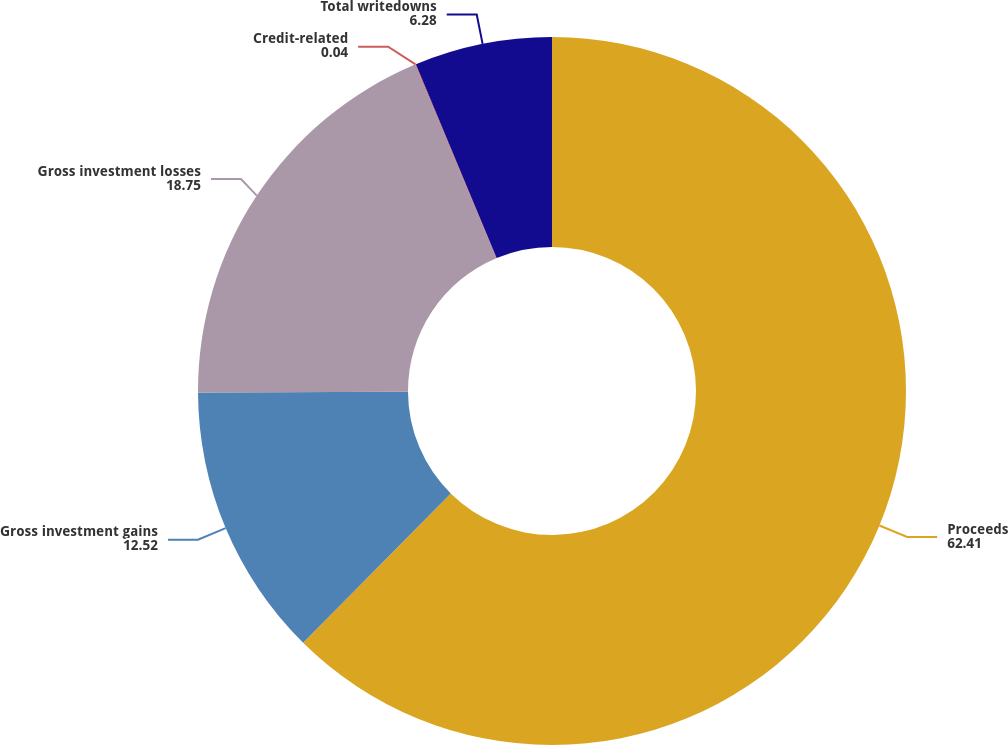Convert chart. <chart><loc_0><loc_0><loc_500><loc_500><pie_chart><fcel>Proceeds<fcel>Gross investment gains<fcel>Gross investment losses<fcel>Credit-related<fcel>Total writedowns<nl><fcel>62.41%<fcel>12.52%<fcel>18.75%<fcel>0.04%<fcel>6.28%<nl></chart> 